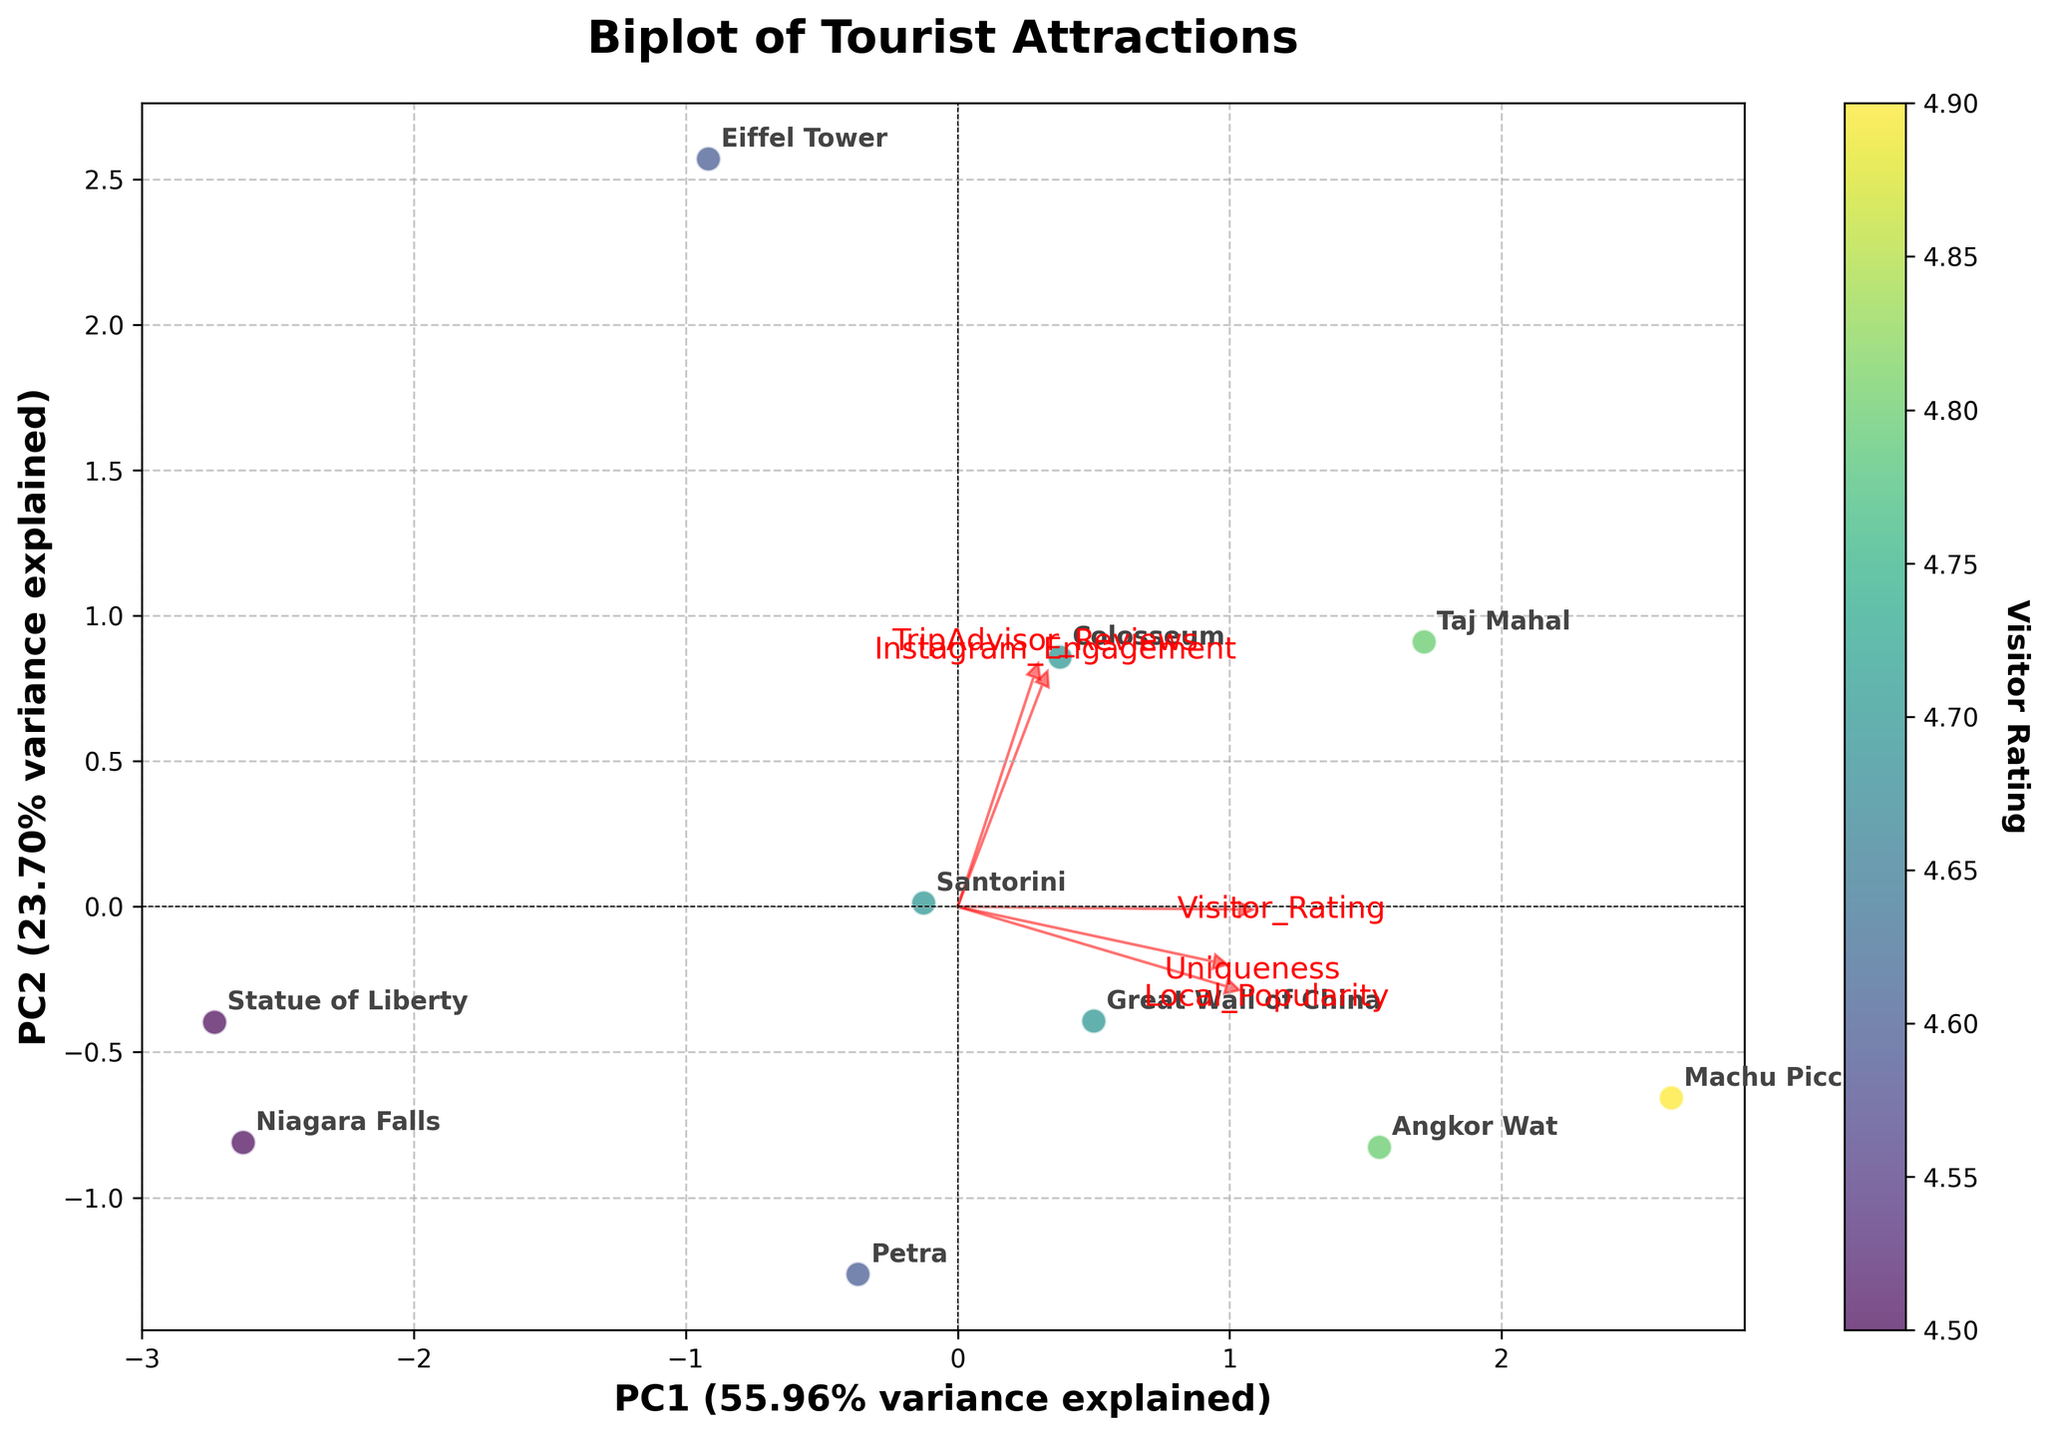How many tourist attractions are there on the plot? Count all the labels provided in the biplot. There are 10 tourist attractions labeled on the plot.
Answer: 10 Which tourist attraction has the highest Visitor Rating? The color of the data points represents the Visitor Rating. Locate the point with the deepest color and its corresponding label. Machu Picchu has the highest Visitor Rating of 4.9.
Answer: Machu Picchu Are local popularity and uniqueness positively correlated based on the loadings? Observe the directions of the arrows representing Local_Popularity and Uniqueness. If they point in the same or similar directions, they are positively correlated. Both arrows point towards a similar direction.
Answer: Yes Which tourist attraction is mapped closest to PC1 axis? Find the point that is nearest to the x-axis (PC1) among the data points. The Eiffel Tower is located closest to the PC1 axis.
Answer: Eiffel Tower How much variance is explained by PC1? Refer to the x-axis label, which provides the percentage of variance explained by PC1. The label indicates that PC1 explains approximately 51.20% of the variance.
Answer: 51.20% Which features have the largest impact on the PC2 axis? Identify the arrows that are longest in the vertical (y-axis/PC2) direction. The features Uniqueness and Local_Popularity have the largest impact on the PC2 axis due to their longer vertical arrows.
Answer: Uniqueness, Local_Popularity Is Instagram Engagement more aligned with PC1 or PC2? Observe the direction of the Instagram_Engagement arrow and align it with the x-axis (PC1) and y-axis (PC2). The arrow is more aligned with PC1.
Answer: PC1 How does the Statue of Liberty compare to the Great Wall of China in terms of Instagram Engagement? Look at the positions of both attractions in relation to the Instagram_Engagement arrow. The Great Wall of China is closer to the Instagram_Engagement arrow, indicating higher engagement compared to the Statue of Liberty.
Answer: Great Wall of China has higher engagement Which feature is least aligned with PC1? Observe the arrows for each feature and compare their alignment with the horizontal axis (PC1). The feature Uniqueness is least aligned with PC1 due to its near-vertical arrow.
Answer: Uniqueness 